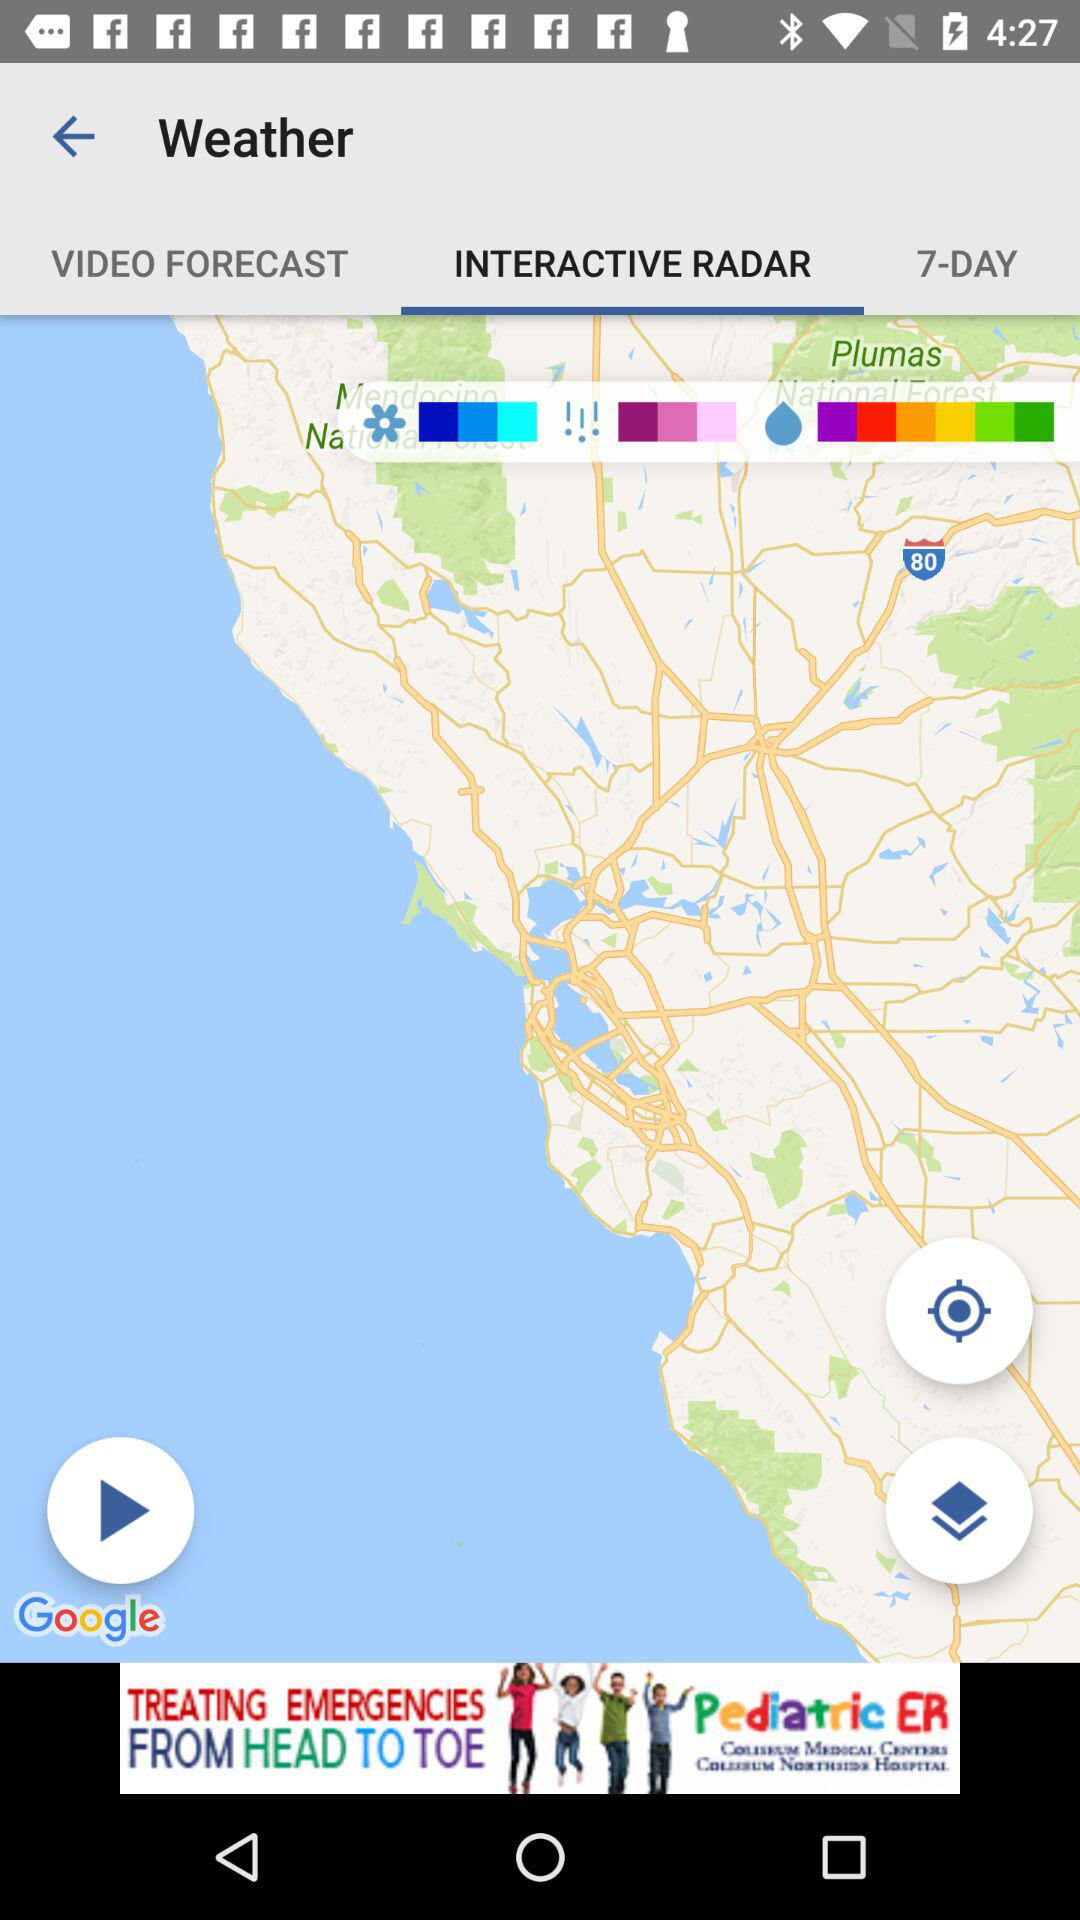What is the entered location?
When the provided information is insufficient, respond with <no answer>. <no answer> 